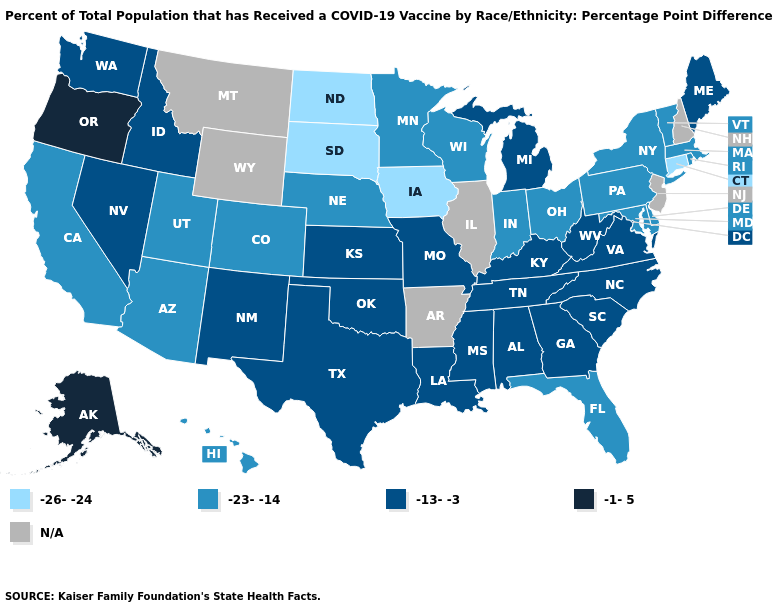What is the value of Rhode Island?
Keep it brief. -23--14. Does Oregon have the highest value in the USA?
Give a very brief answer. Yes. Does Vermont have the highest value in the USA?
Quick response, please. No. What is the lowest value in states that border Louisiana?
Short answer required. -13--3. Is the legend a continuous bar?
Keep it brief. No. What is the highest value in the USA?
Be succinct. -1-5. Which states hav the highest value in the South?
Answer briefly. Alabama, Georgia, Kentucky, Louisiana, Mississippi, North Carolina, Oklahoma, South Carolina, Tennessee, Texas, Virginia, West Virginia. What is the lowest value in states that border Delaware?
Write a very short answer. -23--14. Which states have the lowest value in the USA?
Write a very short answer. Connecticut, Iowa, North Dakota, South Dakota. Name the states that have a value in the range -26--24?
Quick response, please. Connecticut, Iowa, North Dakota, South Dakota. Which states have the lowest value in the USA?
Keep it brief. Connecticut, Iowa, North Dakota, South Dakota. What is the value of Mississippi?
Quick response, please. -13--3. Among the states that border California , does Nevada have the highest value?
Concise answer only. No. What is the value of Michigan?
Write a very short answer. -13--3. 